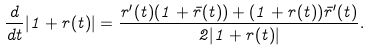<formula> <loc_0><loc_0><loc_500><loc_500>\frac { d } { d t } | 1 + r ( t ) | = \frac { r ^ { \prime } ( t ) ( 1 + \bar { r } ( t ) ) + ( 1 + r ( t ) ) \bar { r } ^ { \prime } ( t ) } { 2 | 1 + r ( t ) | } .</formula> 